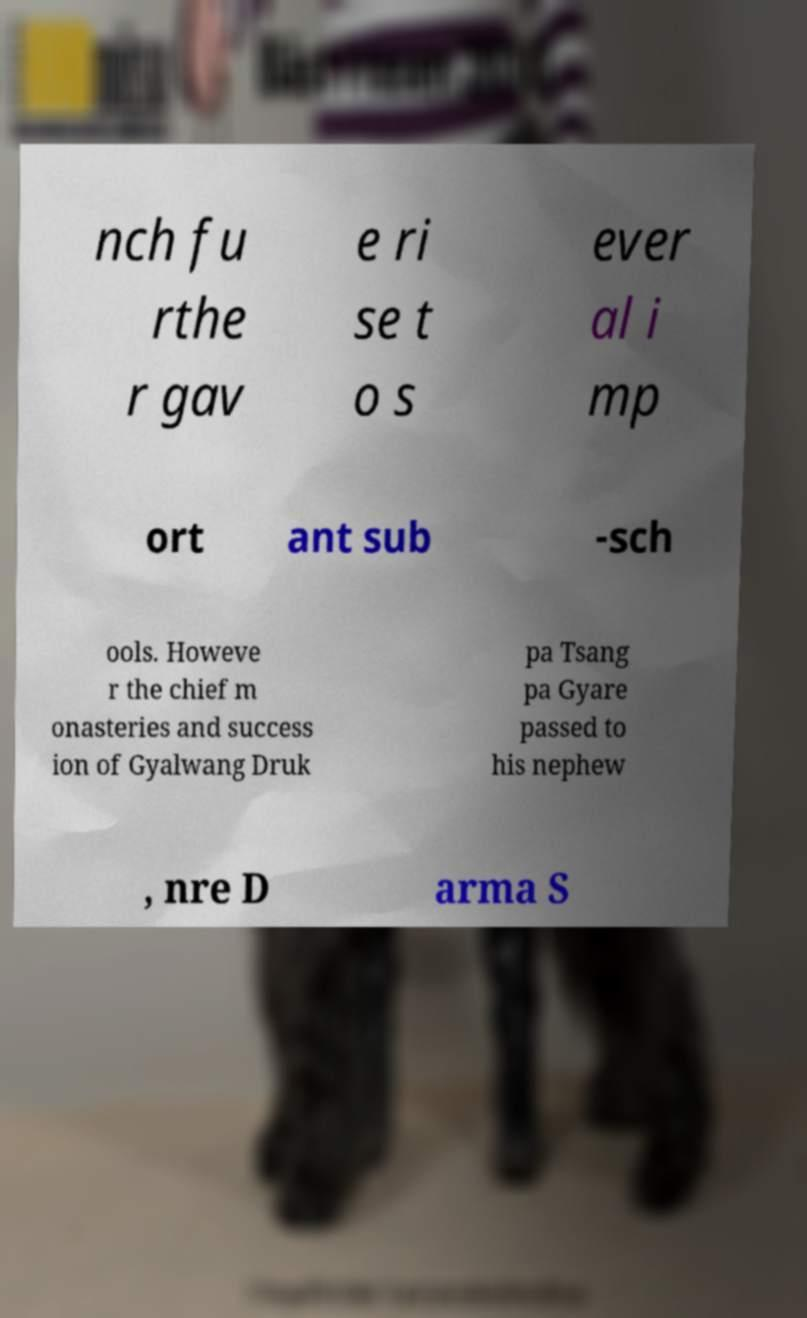Please identify and transcribe the text found in this image. nch fu rthe r gav e ri se t o s ever al i mp ort ant sub -sch ools. Howeve r the chief m onasteries and success ion of Gyalwang Druk pa Tsang pa Gyare passed to his nephew , nre D arma S 